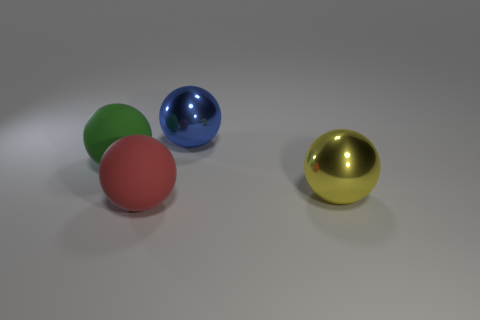Subtract all green matte spheres. How many spheres are left? 3 Add 3 tiny green matte cubes. How many objects exist? 7 Subtract all blue balls. How many balls are left? 3 Subtract 0 cyan balls. How many objects are left? 4 Subtract 4 spheres. How many spheres are left? 0 Subtract all green spheres. Subtract all cyan cylinders. How many spheres are left? 3 Subtract all purple blocks. How many yellow balls are left? 1 Subtract all large yellow shiny spheres. Subtract all gray cylinders. How many objects are left? 3 Add 2 large yellow balls. How many large yellow balls are left? 3 Add 4 large green balls. How many large green balls exist? 5 